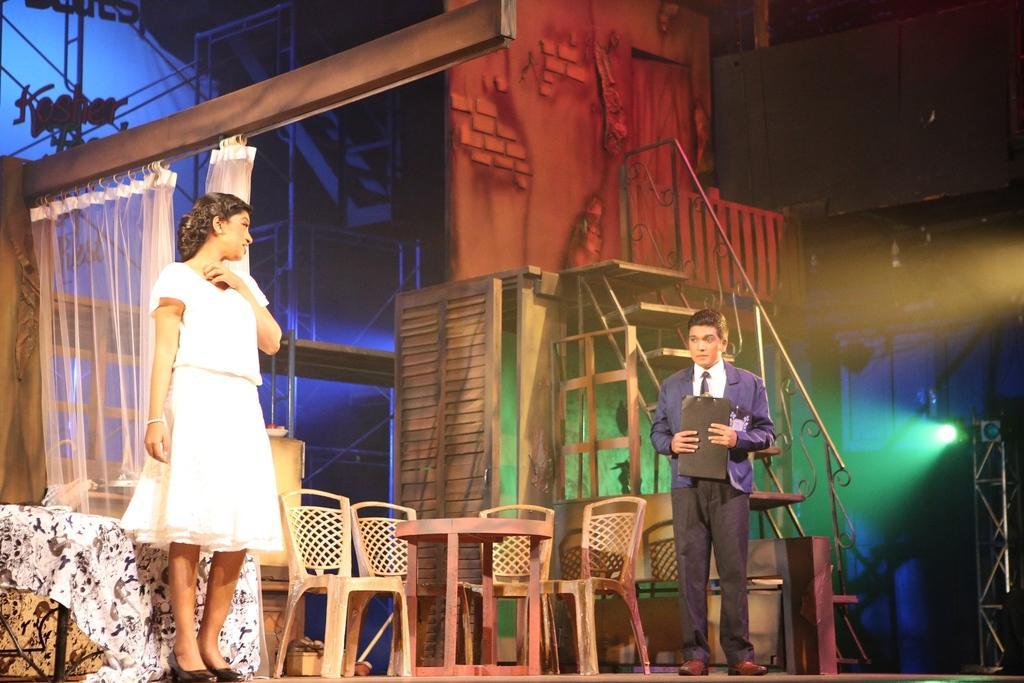Can you describe this image briefly? This might be a picture of a drama. In the picture to the left there is a woman standing. To the right there is a man standing holding a pad. In the center of the picture there is a table and chairs. In the background there are staircase and railing. To the top left there is a bed and curtains. On the left there is a bed covered with bed sheet. In the background we can see iron frame and blue focus light. 